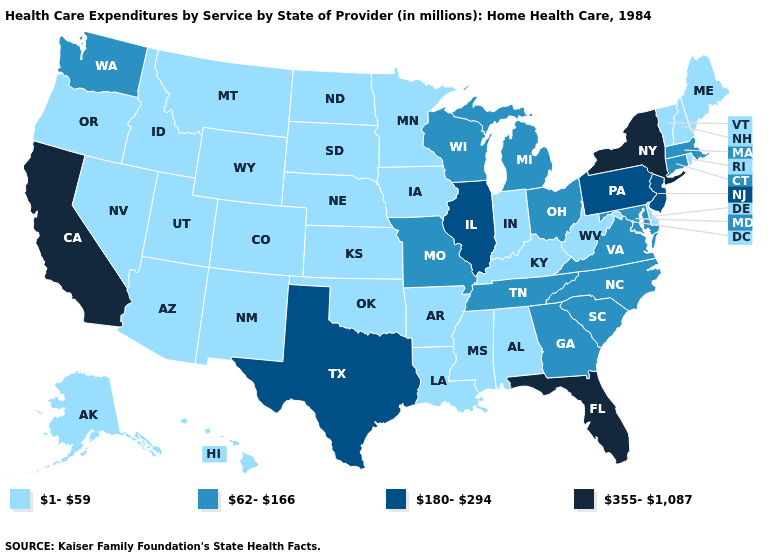Does Mississippi have a lower value than Ohio?
Write a very short answer. Yes. Which states have the highest value in the USA?
Answer briefly. California, Florida, New York. What is the value of Alaska?
Keep it brief. 1-59. Among the states that border Rhode Island , which have the highest value?
Be succinct. Connecticut, Massachusetts. What is the highest value in the Northeast ?
Quick response, please. 355-1,087. Does North Dakota have a lower value than New York?
Be succinct. Yes. What is the value of Nevada?
Concise answer only. 1-59. What is the lowest value in states that border Vermont?
Answer briefly. 1-59. What is the lowest value in the USA?
Concise answer only. 1-59. Among the states that border Minnesota , which have the lowest value?
Short answer required. Iowa, North Dakota, South Dakota. What is the highest value in the USA?
Quick response, please. 355-1,087. Which states hav the highest value in the South?
Answer briefly. Florida. Which states have the lowest value in the USA?
Concise answer only. Alabama, Alaska, Arizona, Arkansas, Colorado, Delaware, Hawaii, Idaho, Indiana, Iowa, Kansas, Kentucky, Louisiana, Maine, Minnesota, Mississippi, Montana, Nebraska, Nevada, New Hampshire, New Mexico, North Dakota, Oklahoma, Oregon, Rhode Island, South Dakota, Utah, Vermont, West Virginia, Wyoming. Does Florida have the lowest value in the South?
Quick response, please. No. Does North Dakota have a higher value than Oregon?
Answer briefly. No. 